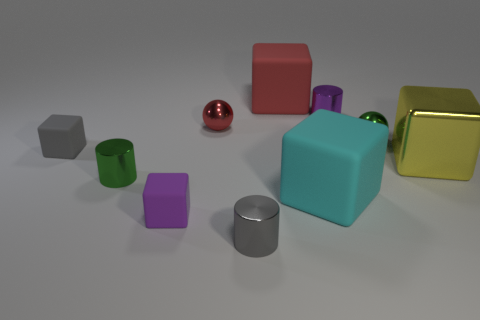Do the tiny purple thing that is on the left side of the tiny purple metallic thing and the tiny cylinder in front of the cyan cube have the same material?
Provide a short and direct response. No. Is there anything else that has the same material as the big cyan block?
Your answer should be very brief. Yes. Does the small metal object in front of the cyan cube have the same shape as the big rubber thing that is in front of the purple shiny thing?
Your response must be concise. No. Is the number of green objects that are to the left of the tiny green sphere less than the number of small green cylinders?
Provide a short and direct response. No. What number of metal cylinders have the same color as the large metal thing?
Your response must be concise. 0. How big is the purple object that is behind the tiny gray rubber object?
Give a very brief answer. Small. There is a tiny purple object that is in front of the purple thing that is to the right of the large cube behind the small green metal ball; what shape is it?
Your answer should be very brief. Cube. There is a matte thing that is in front of the large red object and right of the small purple matte object; what shape is it?
Make the answer very short. Cube. Is there a shiny cylinder of the same size as the yellow metal cube?
Give a very brief answer. No. Do the tiny green metallic object in front of the large metallic object and the large cyan thing have the same shape?
Offer a very short reply. No. 